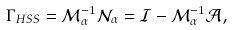<formula> <loc_0><loc_0><loc_500><loc_500>{ \Gamma } _ { H S S } = { \mathcal { M } } _ { \alpha } ^ { - 1 } { \mathcal { N } } _ { \alpha } = \mathcal { I } - { \mathcal { M } } _ { \alpha } ^ { - 1 } \mathcal { A } ,</formula> 